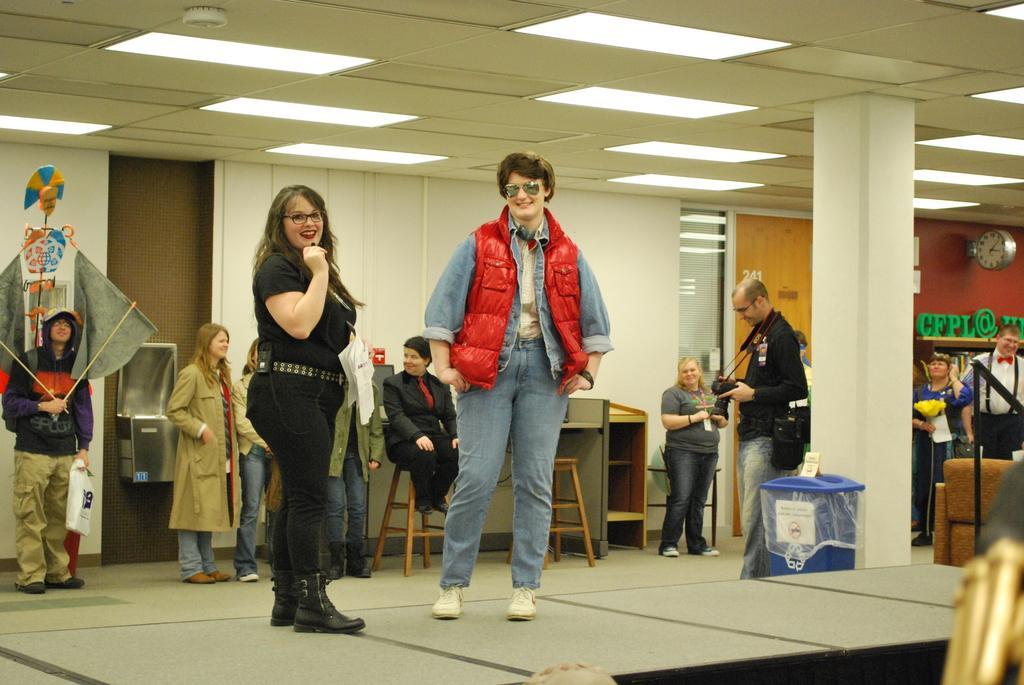Could you give a brief overview of what you see in this image? In this image we can see a group of people standing on the floor. To the right side of the image we can see a sofa, poles, trash bin placed on the ground. One person is holding a camera in his hands. To the left side of the image we can see a person holding sticks with his hand and a bag in the other hand. In the background, we can see a metal container on the wall. One person is sitting on chair, table, some books and some letter places on the racks, a clock on the wall, pillar and group of lights. 